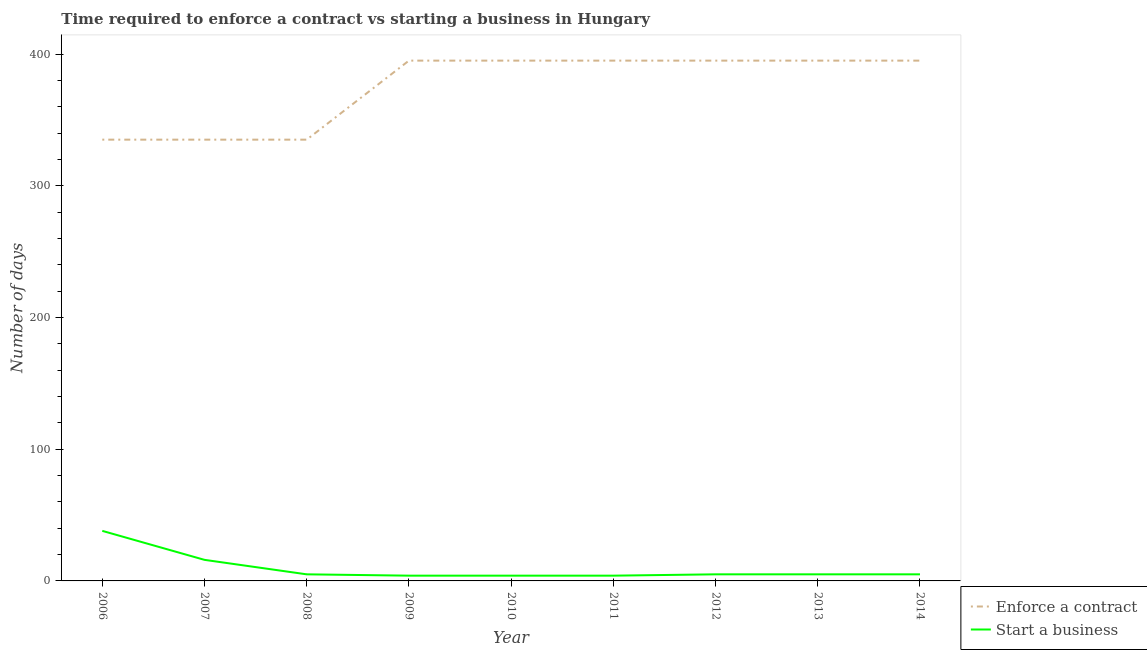Does the line corresponding to number of days to start a business intersect with the line corresponding to number of days to enforece a contract?
Ensure brevity in your answer.  No. What is the number of days to enforece a contract in 2012?
Give a very brief answer. 395. Across all years, what is the maximum number of days to enforece a contract?
Make the answer very short. 395. Across all years, what is the minimum number of days to start a business?
Your response must be concise. 4. What is the total number of days to start a business in the graph?
Your response must be concise. 86. What is the difference between the number of days to start a business in 2008 and that in 2011?
Give a very brief answer. 1. What is the difference between the number of days to start a business in 2011 and the number of days to enforece a contract in 2014?
Ensure brevity in your answer.  -391. What is the average number of days to enforece a contract per year?
Make the answer very short. 375. In the year 2014, what is the difference between the number of days to enforece a contract and number of days to start a business?
Keep it short and to the point. 390. What is the ratio of the number of days to enforece a contract in 2011 to that in 2014?
Give a very brief answer. 1. Is the difference between the number of days to start a business in 2007 and 2008 greater than the difference between the number of days to enforece a contract in 2007 and 2008?
Your answer should be compact. Yes. What is the difference between the highest and the lowest number of days to enforece a contract?
Your answer should be compact. 60. In how many years, is the number of days to enforece a contract greater than the average number of days to enforece a contract taken over all years?
Your answer should be compact. 6. Is the number of days to enforece a contract strictly greater than the number of days to start a business over the years?
Your answer should be compact. Yes. Is the number of days to enforece a contract strictly less than the number of days to start a business over the years?
Offer a very short reply. No. How many lines are there?
Keep it short and to the point. 2. What is the difference between two consecutive major ticks on the Y-axis?
Your response must be concise. 100. Are the values on the major ticks of Y-axis written in scientific E-notation?
Give a very brief answer. No. How many legend labels are there?
Provide a succinct answer. 2. How are the legend labels stacked?
Provide a succinct answer. Vertical. What is the title of the graph?
Ensure brevity in your answer.  Time required to enforce a contract vs starting a business in Hungary. What is the label or title of the Y-axis?
Make the answer very short. Number of days. What is the Number of days of Enforce a contract in 2006?
Your answer should be very brief. 335. What is the Number of days in Enforce a contract in 2007?
Your response must be concise. 335. What is the Number of days in Start a business in 2007?
Offer a very short reply. 16. What is the Number of days in Enforce a contract in 2008?
Provide a short and direct response. 335. What is the Number of days of Start a business in 2008?
Give a very brief answer. 5. What is the Number of days in Enforce a contract in 2009?
Provide a succinct answer. 395. What is the Number of days in Start a business in 2009?
Make the answer very short. 4. What is the Number of days in Enforce a contract in 2010?
Your answer should be very brief. 395. What is the Number of days of Enforce a contract in 2011?
Provide a succinct answer. 395. What is the Number of days of Start a business in 2011?
Offer a terse response. 4. What is the Number of days in Enforce a contract in 2012?
Ensure brevity in your answer.  395. What is the Number of days in Enforce a contract in 2013?
Your answer should be very brief. 395. What is the Number of days in Start a business in 2013?
Provide a short and direct response. 5. What is the Number of days in Enforce a contract in 2014?
Your answer should be very brief. 395. Across all years, what is the maximum Number of days of Enforce a contract?
Provide a succinct answer. 395. Across all years, what is the maximum Number of days of Start a business?
Your answer should be compact. 38. Across all years, what is the minimum Number of days in Enforce a contract?
Ensure brevity in your answer.  335. Across all years, what is the minimum Number of days in Start a business?
Give a very brief answer. 4. What is the total Number of days of Enforce a contract in the graph?
Keep it short and to the point. 3375. What is the difference between the Number of days of Enforce a contract in 2006 and that in 2007?
Give a very brief answer. 0. What is the difference between the Number of days of Enforce a contract in 2006 and that in 2009?
Ensure brevity in your answer.  -60. What is the difference between the Number of days in Enforce a contract in 2006 and that in 2010?
Provide a succinct answer. -60. What is the difference between the Number of days in Enforce a contract in 2006 and that in 2011?
Offer a terse response. -60. What is the difference between the Number of days in Enforce a contract in 2006 and that in 2012?
Offer a terse response. -60. What is the difference between the Number of days in Start a business in 2006 and that in 2012?
Give a very brief answer. 33. What is the difference between the Number of days of Enforce a contract in 2006 and that in 2013?
Provide a succinct answer. -60. What is the difference between the Number of days in Start a business in 2006 and that in 2013?
Provide a succinct answer. 33. What is the difference between the Number of days of Enforce a contract in 2006 and that in 2014?
Ensure brevity in your answer.  -60. What is the difference between the Number of days in Enforce a contract in 2007 and that in 2008?
Keep it short and to the point. 0. What is the difference between the Number of days in Start a business in 2007 and that in 2008?
Provide a short and direct response. 11. What is the difference between the Number of days of Enforce a contract in 2007 and that in 2009?
Your answer should be very brief. -60. What is the difference between the Number of days of Start a business in 2007 and that in 2009?
Provide a short and direct response. 12. What is the difference between the Number of days of Enforce a contract in 2007 and that in 2010?
Provide a short and direct response. -60. What is the difference between the Number of days of Enforce a contract in 2007 and that in 2011?
Offer a very short reply. -60. What is the difference between the Number of days in Enforce a contract in 2007 and that in 2012?
Offer a terse response. -60. What is the difference between the Number of days in Start a business in 2007 and that in 2012?
Give a very brief answer. 11. What is the difference between the Number of days of Enforce a contract in 2007 and that in 2013?
Provide a succinct answer. -60. What is the difference between the Number of days of Start a business in 2007 and that in 2013?
Ensure brevity in your answer.  11. What is the difference between the Number of days of Enforce a contract in 2007 and that in 2014?
Your response must be concise. -60. What is the difference between the Number of days in Start a business in 2007 and that in 2014?
Provide a succinct answer. 11. What is the difference between the Number of days in Enforce a contract in 2008 and that in 2009?
Ensure brevity in your answer.  -60. What is the difference between the Number of days in Start a business in 2008 and that in 2009?
Your answer should be compact. 1. What is the difference between the Number of days in Enforce a contract in 2008 and that in 2010?
Provide a succinct answer. -60. What is the difference between the Number of days in Start a business in 2008 and that in 2010?
Your answer should be very brief. 1. What is the difference between the Number of days in Enforce a contract in 2008 and that in 2011?
Provide a short and direct response. -60. What is the difference between the Number of days in Enforce a contract in 2008 and that in 2012?
Offer a terse response. -60. What is the difference between the Number of days of Enforce a contract in 2008 and that in 2013?
Make the answer very short. -60. What is the difference between the Number of days in Enforce a contract in 2008 and that in 2014?
Ensure brevity in your answer.  -60. What is the difference between the Number of days in Enforce a contract in 2009 and that in 2010?
Keep it short and to the point. 0. What is the difference between the Number of days in Start a business in 2009 and that in 2010?
Your answer should be compact. 0. What is the difference between the Number of days in Enforce a contract in 2009 and that in 2011?
Make the answer very short. 0. What is the difference between the Number of days in Start a business in 2009 and that in 2011?
Provide a succinct answer. 0. What is the difference between the Number of days of Enforce a contract in 2009 and that in 2012?
Offer a very short reply. 0. What is the difference between the Number of days in Start a business in 2009 and that in 2012?
Ensure brevity in your answer.  -1. What is the difference between the Number of days of Start a business in 2009 and that in 2013?
Provide a succinct answer. -1. What is the difference between the Number of days of Enforce a contract in 2009 and that in 2014?
Offer a very short reply. 0. What is the difference between the Number of days in Enforce a contract in 2010 and that in 2011?
Make the answer very short. 0. What is the difference between the Number of days of Enforce a contract in 2010 and that in 2012?
Offer a very short reply. 0. What is the difference between the Number of days in Start a business in 2010 and that in 2012?
Provide a succinct answer. -1. What is the difference between the Number of days of Enforce a contract in 2010 and that in 2013?
Offer a very short reply. 0. What is the difference between the Number of days in Start a business in 2010 and that in 2014?
Your answer should be compact. -1. What is the difference between the Number of days in Enforce a contract in 2011 and that in 2012?
Offer a very short reply. 0. What is the difference between the Number of days of Enforce a contract in 2011 and that in 2013?
Keep it short and to the point. 0. What is the difference between the Number of days of Start a business in 2011 and that in 2013?
Provide a succinct answer. -1. What is the difference between the Number of days of Start a business in 2011 and that in 2014?
Offer a very short reply. -1. What is the difference between the Number of days in Start a business in 2012 and that in 2013?
Make the answer very short. 0. What is the difference between the Number of days of Enforce a contract in 2006 and the Number of days of Start a business in 2007?
Ensure brevity in your answer.  319. What is the difference between the Number of days of Enforce a contract in 2006 and the Number of days of Start a business in 2008?
Ensure brevity in your answer.  330. What is the difference between the Number of days of Enforce a contract in 2006 and the Number of days of Start a business in 2009?
Offer a very short reply. 331. What is the difference between the Number of days of Enforce a contract in 2006 and the Number of days of Start a business in 2010?
Offer a very short reply. 331. What is the difference between the Number of days of Enforce a contract in 2006 and the Number of days of Start a business in 2011?
Keep it short and to the point. 331. What is the difference between the Number of days of Enforce a contract in 2006 and the Number of days of Start a business in 2012?
Provide a short and direct response. 330. What is the difference between the Number of days of Enforce a contract in 2006 and the Number of days of Start a business in 2013?
Provide a succinct answer. 330. What is the difference between the Number of days of Enforce a contract in 2006 and the Number of days of Start a business in 2014?
Give a very brief answer. 330. What is the difference between the Number of days in Enforce a contract in 2007 and the Number of days in Start a business in 2008?
Offer a very short reply. 330. What is the difference between the Number of days of Enforce a contract in 2007 and the Number of days of Start a business in 2009?
Give a very brief answer. 331. What is the difference between the Number of days of Enforce a contract in 2007 and the Number of days of Start a business in 2010?
Ensure brevity in your answer.  331. What is the difference between the Number of days in Enforce a contract in 2007 and the Number of days in Start a business in 2011?
Offer a terse response. 331. What is the difference between the Number of days in Enforce a contract in 2007 and the Number of days in Start a business in 2012?
Make the answer very short. 330. What is the difference between the Number of days of Enforce a contract in 2007 and the Number of days of Start a business in 2013?
Offer a very short reply. 330. What is the difference between the Number of days of Enforce a contract in 2007 and the Number of days of Start a business in 2014?
Your answer should be very brief. 330. What is the difference between the Number of days of Enforce a contract in 2008 and the Number of days of Start a business in 2009?
Your answer should be very brief. 331. What is the difference between the Number of days of Enforce a contract in 2008 and the Number of days of Start a business in 2010?
Provide a short and direct response. 331. What is the difference between the Number of days in Enforce a contract in 2008 and the Number of days in Start a business in 2011?
Provide a short and direct response. 331. What is the difference between the Number of days of Enforce a contract in 2008 and the Number of days of Start a business in 2012?
Your answer should be compact. 330. What is the difference between the Number of days of Enforce a contract in 2008 and the Number of days of Start a business in 2013?
Your answer should be compact. 330. What is the difference between the Number of days of Enforce a contract in 2008 and the Number of days of Start a business in 2014?
Give a very brief answer. 330. What is the difference between the Number of days in Enforce a contract in 2009 and the Number of days in Start a business in 2010?
Keep it short and to the point. 391. What is the difference between the Number of days in Enforce a contract in 2009 and the Number of days in Start a business in 2011?
Your response must be concise. 391. What is the difference between the Number of days in Enforce a contract in 2009 and the Number of days in Start a business in 2012?
Keep it short and to the point. 390. What is the difference between the Number of days in Enforce a contract in 2009 and the Number of days in Start a business in 2013?
Offer a terse response. 390. What is the difference between the Number of days in Enforce a contract in 2009 and the Number of days in Start a business in 2014?
Give a very brief answer. 390. What is the difference between the Number of days in Enforce a contract in 2010 and the Number of days in Start a business in 2011?
Make the answer very short. 391. What is the difference between the Number of days in Enforce a contract in 2010 and the Number of days in Start a business in 2012?
Ensure brevity in your answer.  390. What is the difference between the Number of days of Enforce a contract in 2010 and the Number of days of Start a business in 2013?
Your answer should be very brief. 390. What is the difference between the Number of days of Enforce a contract in 2010 and the Number of days of Start a business in 2014?
Offer a very short reply. 390. What is the difference between the Number of days of Enforce a contract in 2011 and the Number of days of Start a business in 2012?
Provide a succinct answer. 390. What is the difference between the Number of days in Enforce a contract in 2011 and the Number of days in Start a business in 2013?
Your answer should be very brief. 390. What is the difference between the Number of days in Enforce a contract in 2011 and the Number of days in Start a business in 2014?
Your answer should be compact. 390. What is the difference between the Number of days of Enforce a contract in 2012 and the Number of days of Start a business in 2013?
Your answer should be very brief. 390. What is the difference between the Number of days in Enforce a contract in 2012 and the Number of days in Start a business in 2014?
Your response must be concise. 390. What is the difference between the Number of days of Enforce a contract in 2013 and the Number of days of Start a business in 2014?
Offer a very short reply. 390. What is the average Number of days of Enforce a contract per year?
Make the answer very short. 375. What is the average Number of days of Start a business per year?
Your response must be concise. 9.56. In the year 2006, what is the difference between the Number of days of Enforce a contract and Number of days of Start a business?
Provide a short and direct response. 297. In the year 2007, what is the difference between the Number of days in Enforce a contract and Number of days in Start a business?
Provide a short and direct response. 319. In the year 2008, what is the difference between the Number of days in Enforce a contract and Number of days in Start a business?
Offer a very short reply. 330. In the year 2009, what is the difference between the Number of days of Enforce a contract and Number of days of Start a business?
Your answer should be very brief. 391. In the year 2010, what is the difference between the Number of days of Enforce a contract and Number of days of Start a business?
Keep it short and to the point. 391. In the year 2011, what is the difference between the Number of days in Enforce a contract and Number of days in Start a business?
Give a very brief answer. 391. In the year 2012, what is the difference between the Number of days in Enforce a contract and Number of days in Start a business?
Your response must be concise. 390. In the year 2013, what is the difference between the Number of days of Enforce a contract and Number of days of Start a business?
Offer a terse response. 390. In the year 2014, what is the difference between the Number of days of Enforce a contract and Number of days of Start a business?
Your answer should be very brief. 390. What is the ratio of the Number of days of Enforce a contract in 2006 to that in 2007?
Provide a succinct answer. 1. What is the ratio of the Number of days in Start a business in 2006 to that in 2007?
Your response must be concise. 2.38. What is the ratio of the Number of days of Enforce a contract in 2006 to that in 2008?
Provide a short and direct response. 1. What is the ratio of the Number of days of Start a business in 2006 to that in 2008?
Offer a terse response. 7.6. What is the ratio of the Number of days in Enforce a contract in 2006 to that in 2009?
Your answer should be compact. 0.85. What is the ratio of the Number of days in Start a business in 2006 to that in 2009?
Your answer should be compact. 9.5. What is the ratio of the Number of days of Enforce a contract in 2006 to that in 2010?
Keep it short and to the point. 0.85. What is the ratio of the Number of days in Start a business in 2006 to that in 2010?
Offer a very short reply. 9.5. What is the ratio of the Number of days in Enforce a contract in 2006 to that in 2011?
Offer a terse response. 0.85. What is the ratio of the Number of days of Start a business in 2006 to that in 2011?
Your response must be concise. 9.5. What is the ratio of the Number of days in Enforce a contract in 2006 to that in 2012?
Provide a short and direct response. 0.85. What is the ratio of the Number of days in Enforce a contract in 2006 to that in 2013?
Your answer should be very brief. 0.85. What is the ratio of the Number of days of Enforce a contract in 2006 to that in 2014?
Your answer should be very brief. 0.85. What is the ratio of the Number of days of Start a business in 2007 to that in 2008?
Offer a terse response. 3.2. What is the ratio of the Number of days in Enforce a contract in 2007 to that in 2009?
Make the answer very short. 0.85. What is the ratio of the Number of days of Start a business in 2007 to that in 2009?
Keep it short and to the point. 4. What is the ratio of the Number of days of Enforce a contract in 2007 to that in 2010?
Give a very brief answer. 0.85. What is the ratio of the Number of days in Enforce a contract in 2007 to that in 2011?
Give a very brief answer. 0.85. What is the ratio of the Number of days in Start a business in 2007 to that in 2011?
Keep it short and to the point. 4. What is the ratio of the Number of days in Enforce a contract in 2007 to that in 2012?
Offer a very short reply. 0.85. What is the ratio of the Number of days of Start a business in 2007 to that in 2012?
Your answer should be very brief. 3.2. What is the ratio of the Number of days in Enforce a contract in 2007 to that in 2013?
Offer a very short reply. 0.85. What is the ratio of the Number of days of Start a business in 2007 to that in 2013?
Make the answer very short. 3.2. What is the ratio of the Number of days of Enforce a contract in 2007 to that in 2014?
Your answer should be very brief. 0.85. What is the ratio of the Number of days of Start a business in 2007 to that in 2014?
Your answer should be very brief. 3.2. What is the ratio of the Number of days of Enforce a contract in 2008 to that in 2009?
Make the answer very short. 0.85. What is the ratio of the Number of days of Start a business in 2008 to that in 2009?
Ensure brevity in your answer.  1.25. What is the ratio of the Number of days in Enforce a contract in 2008 to that in 2010?
Offer a very short reply. 0.85. What is the ratio of the Number of days of Start a business in 2008 to that in 2010?
Offer a terse response. 1.25. What is the ratio of the Number of days of Enforce a contract in 2008 to that in 2011?
Provide a short and direct response. 0.85. What is the ratio of the Number of days of Start a business in 2008 to that in 2011?
Give a very brief answer. 1.25. What is the ratio of the Number of days in Enforce a contract in 2008 to that in 2012?
Ensure brevity in your answer.  0.85. What is the ratio of the Number of days of Start a business in 2008 to that in 2012?
Offer a very short reply. 1. What is the ratio of the Number of days in Enforce a contract in 2008 to that in 2013?
Offer a terse response. 0.85. What is the ratio of the Number of days in Enforce a contract in 2008 to that in 2014?
Offer a very short reply. 0.85. What is the ratio of the Number of days in Start a business in 2008 to that in 2014?
Ensure brevity in your answer.  1. What is the ratio of the Number of days of Enforce a contract in 2009 to that in 2011?
Provide a succinct answer. 1. What is the ratio of the Number of days of Start a business in 2009 to that in 2011?
Your answer should be compact. 1. What is the ratio of the Number of days of Enforce a contract in 2009 to that in 2014?
Your answer should be compact. 1. What is the ratio of the Number of days in Start a business in 2009 to that in 2014?
Give a very brief answer. 0.8. What is the ratio of the Number of days in Enforce a contract in 2010 to that in 2011?
Your response must be concise. 1. What is the ratio of the Number of days in Start a business in 2010 to that in 2011?
Ensure brevity in your answer.  1. What is the ratio of the Number of days of Enforce a contract in 2010 to that in 2012?
Make the answer very short. 1. What is the ratio of the Number of days in Enforce a contract in 2010 to that in 2013?
Keep it short and to the point. 1. What is the ratio of the Number of days of Enforce a contract in 2010 to that in 2014?
Make the answer very short. 1. What is the ratio of the Number of days in Start a business in 2010 to that in 2014?
Your answer should be compact. 0.8. What is the ratio of the Number of days in Enforce a contract in 2011 to that in 2012?
Your answer should be compact. 1. What is the ratio of the Number of days in Enforce a contract in 2011 to that in 2014?
Your response must be concise. 1. What is the ratio of the Number of days in Enforce a contract in 2012 to that in 2013?
Provide a succinct answer. 1. What is the ratio of the Number of days of Enforce a contract in 2012 to that in 2014?
Offer a terse response. 1. What is the ratio of the Number of days in Start a business in 2013 to that in 2014?
Give a very brief answer. 1. What is the difference between the highest and the second highest Number of days in Start a business?
Offer a very short reply. 22. 